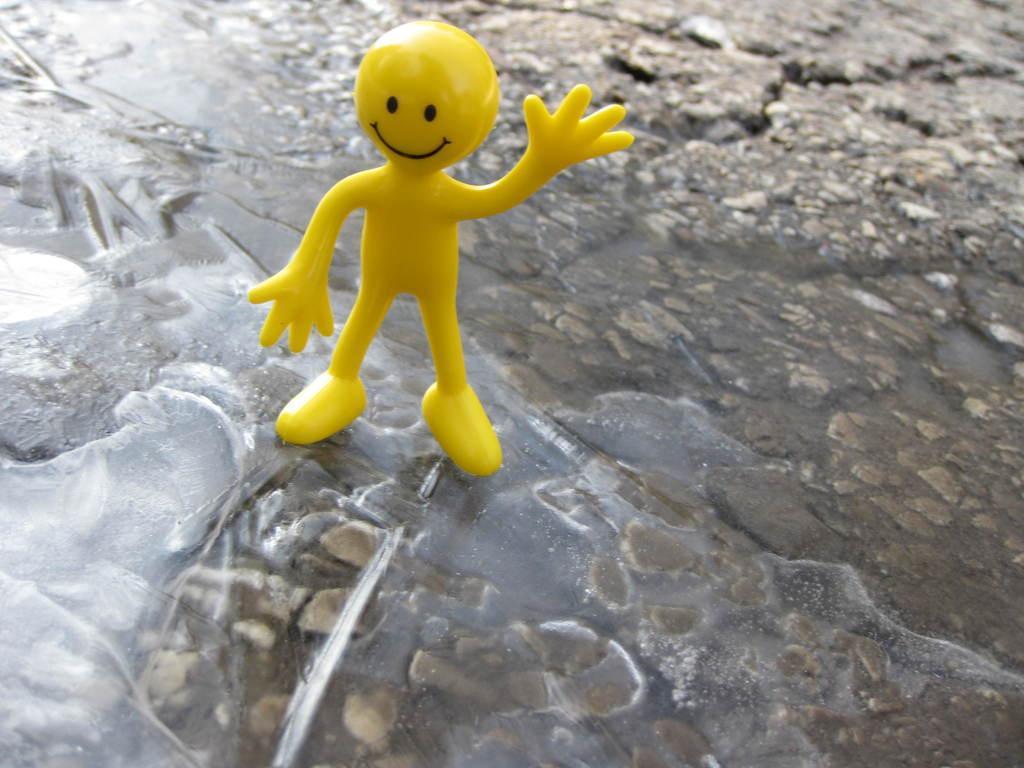In one or two sentences, can you explain what this image depicts? In this image I can see a yellow color toy on a rock. At the bottom, I can see the water. 